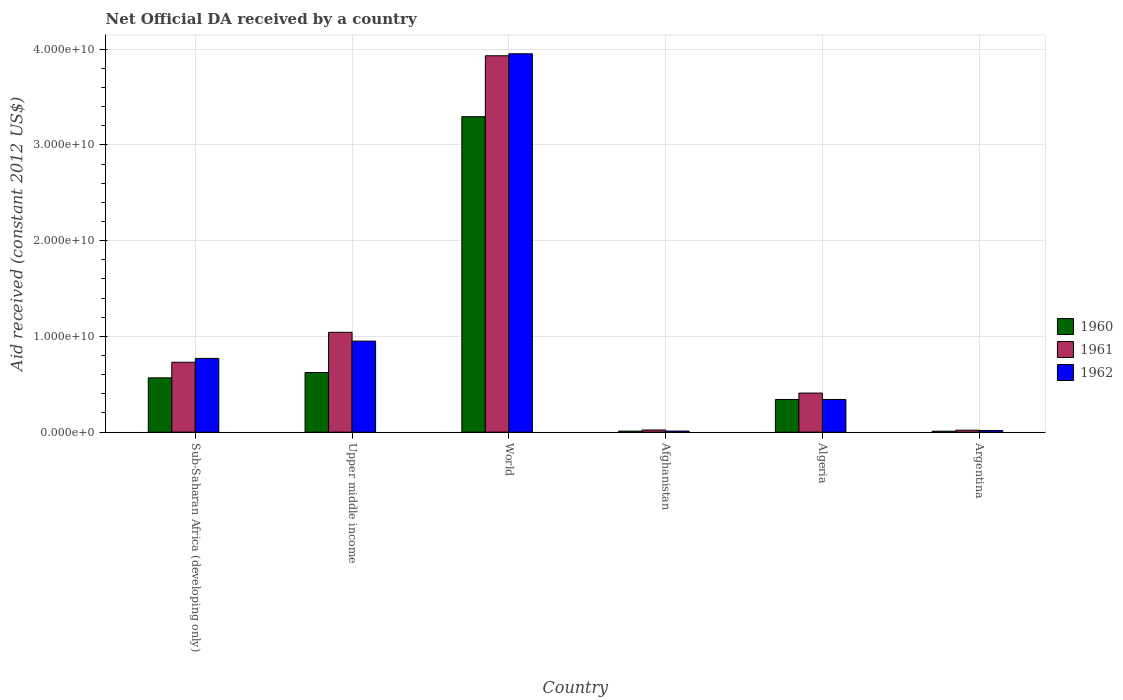Are the number of bars on each tick of the X-axis equal?
Your response must be concise. Yes. How many bars are there on the 2nd tick from the left?
Your answer should be very brief. 3. How many bars are there on the 5th tick from the right?
Give a very brief answer. 3. What is the label of the 4th group of bars from the left?
Provide a short and direct response. Afghanistan. What is the net official development assistance aid received in 1960 in Upper middle income?
Offer a very short reply. 6.23e+09. Across all countries, what is the maximum net official development assistance aid received in 1960?
Keep it short and to the point. 3.29e+1. Across all countries, what is the minimum net official development assistance aid received in 1962?
Offer a terse response. 1.12e+08. In which country was the net official development assistance aid received in 1962 minimum?
Offer a terse response. Afghanistan. What is the total net official development assistance aid received in 1960 in the graph?
Provide a short and direct response. 4.85e+1. What is the difference between the net official development assistance aid received in 1962 in Sub-Saharan Africa (developing only) and that in World?
Your answer should be very brief. -3.18e+1. What is the difference between the net official development assistance aid received in 1962 in Sub-Saharan Africa (developing only) and the net official development assistance aid received in 1961 in Afghanistan?
Provide a short and direct response. 7.47e+09. What is the average net official development assistance aid received in 1961 per country?
Your answer should be compact. 1.03e+1. What is the difference between the net official development assistance aid received of/in 1962 and net official development assistance aid received of/in 1961 in World?
Provide a short and direct response. 2.05e+08. In how many countries, is the net official development assistance aid received in 1960 greater than 2000000000 US$?
Give a very brief answer. 4. What is the ratio of the net official development assistance aid received in 1962 in Afghanistan to that in Argentina?
Offer a terse response. 0.64. Is the net official development assistance aid received in 1962 in Sub-Saharan Africa (developing only) less than that in Upper middle income?
Give a very brief answer. Yes. Is the difference between the net official development assistance aid received in 1962 in Algeria and World greater than the difference between the net official development assistance aid received in 1961 in Algeria and World?
Your answer should be compact. No. What is the difference between the highest and the second highest net official development assistance aid received in 1962?
Ensure brevity in your answer.  3.00e+1. What is the difference between the highest and the lowest net official development assistance aid received in 1962?
Provide a short and direct response. 3.94e+1. Is the sum of the net official development assistance aid received in 1960 in Afghanistan and Argentina greater than the maximum net official development assistance aid received in 1962 across all countries?
Keep it short and to the point. No. Is it the case that in every country, the sum of the net official development assistance aid received in 1962 and net official development assistance aid received in 1960 is greater than the net official development assistance aid received in 1961?
Offer a very short reply. No. How many bars are there?
Your response must be concise. 18. How many countries are there in the graph?
Provide a short and direct response. 6. What is the difference between two consecutive major ticks on the Y-axis?
Your answer should be very brief. 1.00e+1. Are the values on the major ticks of Y-axis written in scientific E-notation?
Ensure brevity in your answer.  Yes. Does the graph contain any zero values?
Offer a terse response. No. Does the graph contain grids?
Provide a succinct answer. Yes. How many legend labels are there?
Provide a short and direct response. 3. How are the legend labels stacked?
Provide a short and direct response. Vertical. What is the title of the graph?
Offer a very short reply. Net Official DA received by a country. What is the label or title of the Y-axis?
Provide a succinct answer. Aid received (constant 2012 US$). What is the Aid received (constant 2012 US$) of 1960 in Sub-Saharan Africa (developing only)?
Offer a terse response. 5.67e+09. What is the Aid received (constant 2012 US$) of 1961 in Sub-Saharan Africa (developing only)?
Your response must be concise. 7.30e+09. What is the Aid received (constant 2012 US$) in 1962 in Sub-Saharan Africa (developing only)?
Make the answer very short. 7.70e+09. What is the Aid received (constant 2012 US$) in 1960 in Upper middle income?
Provide a short and direct response. 6.23e+09. What is the Aid received (constant 2012 US$) in 1961 in Upper middle income?
Your answer should be very brief. 1.04e+1. What is the Aid received (constant 2012 US$) of 1962 in Upper middle income?
Offer a very short reply. 9.51e+09. What is the Aid received (constant 2012 US$) of 1960 in World?
Offer a terse response. 3.29e+1. What is the Aid received (constant 2012 US$) of 1961 in World?
Provide a succinct answer. 3.93e+1. What is the Aid received (constant 2012 US$) in 1962 in World?
Provide a short and direct response. 3.95e+1. What is the Aid received (constant 2012 US$) in 1960 in Afghanistan?
Give a very brief answer. 1.10e+08. What is the Aid received (constant 2012 US$) in 1961 in Afghanistan?
Ensure brevity in your answer.  2.26e+08. What is the Aid received (constant 2012 US$) of 1962 in Afghanistan?
Keep it short and to the point. 1.12e+08. What is the Aid received (constant 2012 US$) of 1960 in Algeria?
Keep it short and to the point. 3.41e+09. What is the Aid received (constant 2012 US$) in 1961 in Algeria?
Keep it short and to the point. 4.08e+09. What is the Aid received (constant 2012 US$) of 1962 in Algeria?
Make the answer very short. 3.41e+09. What is the Aid received (constant 2012 US$) of 1960 in Argentina?
Offer a very short reply. 9.55e+07. What is the Aid received (constant 2012 US$) of 1961 in Argentina?
Offer a very short reply. 2.05e+08. What is the Aid received (constant 2012 US$) in 1962 in Argentina?
Keep it short and to the point. 1.75e+08. Across all countries, what is the maximum Aid received (constant 2012 US$) of 1960?
Ensure brevity in your answer.  3.29e+1. Across all countries, what is the maximum Aid received (constant 2012 US$) in 1961?
Keep it short and to the point. 3.93e+1. Across all countries, what is the maximum Aid received (constant 2012 US$) of 1962?
Your answer should be compact. 3.95e+1. Across all countries, what is the minimum Aid received (constant 2012 US$) in 1960?
Ensure brevity in your answer.  9.55e+07. Across all countries, what is the minimum Aid received (constant 2012 US$) of 1961?
Ensure brevity in your answer.  2.05e+08. Across all countries, what is the minimum Aid received (constant 2012 US$) in 1962?
Ensure brevity in your answer.  1.12e+08. What is the total Aid received (constant 2012 US$) of 1960 in the graph?
Offer a very short reply. 4.85e+1. What is the total Aid received (constant 2012 US$) in 1961 in the graph?
Offer a terse response. 6.15e+1. What is the total Aid received (constant 2012 US$) in 1962 in the graph?
Offer a very short reply. 6.04e+1. What is the difference between the Aid received (constant 2012 US$) of 1960 in Sub-Saharan Africa (developing only) and that in Upper middle income?
Make the answer very short. -5.58e+08. What is the difference between the Aid received (constant 2012 US$) in 1961 in Sub-Saharan Africa (developing only) and that in Upper middle income?
Ensure brevity in your answer.  -3.13e+09. What is the difference between the Aid received (constant 2012 US$) in 1962 in Sub-Saharan Africa (developing only) and that in Upper middle income?
Your answer should be very brief. -1.81e+09. What is the difference between the Aid received (constant 2012 US$) in 1960 in Sub-Saharan Africa (developing only) and that in World?
Give a very brief answer. -2.73e+1. What is the difference between the Aid received (constant 2012 US$) in 1961 in Sub-Saharan Africa (developing only) and that in World?
Provide a succinct answer. -3.20e+1. What is the difference between the Aid received (constant 2012 US$) of 1962 in Sub-Saharan Africa (developing only) and that in World?
Your answer should be very brief. -3.18e+1. What is the difference between the Aid received (constant 2012 US$) in 1960 in Sub-Saharan Africa (developing only) and that in Afghanistan?
Offer a very short reply. 5.56e+09. What is the difference between the Aid received (constant 2012 US$) in 1961 in Sub-Saharan Africa (developing only) and that in Afghanistan?
Your answer should be very brief. 7.07e+09. What is the difference between the Aid received (constant 2012 US$) in 1962 in Sub-Saharan Africa (developing only) and that in Afghanistan?
Keep it short and to the point. 7.59e+09. What is the difference between the Aid received (constant 2012 US$) in 1960 in Sub-Saharan Africa (developing only) and that in Algeria?
Make the answer very short. 2.26e+09. What is the difference between the Aid received (constant 2012 US$) of 1961 in Sub-Saharan Africa (developing only) and that in Algeria?
Offer a terse response. 3.22e+09. What is the difference between the Aid received (constant 2012 US$) of 1962 in Sub-Saharan Africa (developing only) and that in Algeria?
Offer a very short reply. 4.29e+09. What is the difference between the Aid received (constant 2012 US$) of 1960 in Sub-Saharan Africa (developing only) and that in Argentina?
Provide a short and direct response. 5.58e+09. What is the difference between the Aid received (constant 2012 US$) of 1961 in Sub-Saharan Africa (developing only) and that in Argentina?
Offer a very short reply. 7.09e+09. What is the difference between the Aid received (constant 2012 US$) in 1962 in Sub-Saharan Africa (developing only) and that in Argentina?
Your answer should be compact. 7.52e+09. What is the difference between the Aid received (constant 2012 US$) of 1960 in Upper middle income and that in World?
Make the answer very short. -2.67e+1. What is the difference between the Aid received (constant 2012 US$) of 1961 in Upper middle income and that in World?
Provide a succinct answer. -2.89e+1. What is the difference between the Aid received (constant 2012 US$) of 1962 in Upper middle income and that in World?
Make the answer very short. -3.00e+1. What is the difference between the Aid received (constant 2012 US$) in 1960 in Upper middle income and that in Afghanistan?
Keep it short and to the point. 6.12e+09. What is the difference between the Aid received (constant 2012 US$) of 1961 in Upper middle income and that in Afghanistan?
Offer a very short reply. 1.02e+1. What is the difference between the Aid received (constant 2012 US$) of 1962 in Upper middle income and that in Afghanistan?
Provide a succinct answer. 9.39e+09. What is the difference between the Aid received (constant 2012 US$) of 1960 in Upper middle income and that in Algeria?
Your answer should be compact. 2.82e+09. What is the difference between the Aid received (constant 2012 US$) of 1961 in Upper middle income and that in Algeria?
Offer a terse response. 6.35e+09. What is the difference between the Aid received (constant 2012 US$) in 1962 in Upper middle income and that in Algeria?
Ensure brevity in your answer.  6.09e+09. What is the difference between the Aid received (constant 2012 US$) in 1960 in Upper middle income and that in Argentina?
Provide a succinct answer. 6.13e+09. What is the difference between the Aid received (constant 2012 US$) of 1961 in Upper middle income and that in Argentina?
Your answer should be very brief. 1.02e+1. What is the difference between the Aid received (constant 2012 US$) in 1962 in Upper middle income and that in Argentina?
Your answer should be compact. 9.33e+09. What is the difference between the Aid received (constant 2012 US$) of 1960 in World and that in Afghanistan?
Offer a terse response. 3.28e+1. What is the difference between the Aid received (constant 2012 US$) of 1961 in World and that in Afghanistan?
Make the answer very short. 3.91e+1. What is the difference between the Aid received (constant 2012 US$) in 1962 in World and that in Afghanistan?
Keep it short and to the point. 3.94e+1. What is the difference between the Aid received (constant 2012 US$) in 1960 in World and that in Algeria?
Your response must be concise. 2.95e+1. What is the difference between the Aid received (constant 2012 US$) in 1961 in World and that in Algeria?
Your answer should be compact. 3.52e+1. What is the difference between the Aid received (constant 2012 US$) of 1962 in World and that in Algeria?
Give a very brief answer. 3.61e+1. What is the difference between the Aid received (constant 2012 US$) in 1960 in World and that in Argentina?
Your answer should be very brief. 3.28e+1. What is the difference between the Aid received (constant 2012 US$) in 1961 in World and that in Argentina?
Ensure brevity in your answer.  3.91e+1. What is the difference between the Aid received (constant 2012 US$) in 1962 in World and that in Argentina?
Give a very brief answer. 3.93e+1. What is the difference between the Aid received (constant 2012 US$) in 1960 in Afghanistan and that in Algeria?
Make the answer very short. -3.30e+09. What is the difference between the Aid received (constant 2012 US$) in 1961 in Afghanistan and that in Algeria?
Keep it short and to the point. -3.85e+09. What is the difference between the Aid received (constant 2012 US$) in 1962 in Afghanistan and that in Algeria?
Ensure brevity in your answer.  -3.30e+09. What is the difference between the Aid received (constant 2012 US$) of 1960 in Afghanistan and that in Argentina?
Offer a terse response. 1.43e+07. What is the difference between the Aid received (constant 2012 US$) in 1961 in Afghanistan and that in Argentina?
Your answer should be very brief. 2.05e+07. What is the difference between the Aid received (constant 2012 US$) of 1962 in Afghanistan and that in Argentina?
Keep it short and to the point. -6.28e+07. What is the difference between the Aid received (constant 2012 US$) in 1960 in Algeria and that in Argentina?
Ensure brevity in your answer.  3.32e+09. What is the difference between the Aid received (constant 2012 US$) of 1961 in Algeria and that in Argentina?
Give a very brief answer. 3.88e+09. What is the difference between the Aid received (constant 2012 US$) of 1962 in Algeria and that in Argentina?
Keep it short and to the point. 3.24e+09. What is the difference between the Aid received (constant 2012 US$) in 1960 in Sub-Saharan Africa (developing only) and the Aid received (constant 2012 US$) in 1961 in Upper middle income?
Offer a terse response. -4.76e+09. What is the difference between the Aid received (constant 2012 US$) of 1960 in Sub-Saharan Africa (developing only) and the Aid received (constant 2012 US$) of 1962 in Upper middle income?
Keep it short and to the point. -3.83e+09. What is the difference between the Aid received (constant 2012 US$) of 1961 in Sub-Saharan Africa (developing only) and the Aid received (constant 2012 US$) of 1962 in Upper middle income?
Make the answer very short. -2.21e+09. What is the difference between the Aid received (constant 2012 US$) in 1960 in Sub-Saharan Africa (developing only) and the Aid received (constant 2012 US$) in 1961 in World?
Offer a terse response. -3.36e+1. What is the difference between the Aid received (constant 2012 US$) of 1960 in Sub-Saharan Africa (developing only) and the Aid received (constant 2012 US$) of 1962 in World?
Your answer should be compact. -3.38e+1. What is the difference between the Aid received (constant 2012 US$) in 1961 in Sub-Saharan Africa (developing only) and the Aid received (constant 2012 US$) in 1962 in World?
Your response must be concise. -3.22e+1. What is the difference between the Aid received (constant 2012 US$) in 1960 in Sub-Saharan Africa (developing only) and the Aid received (constant 2012 US$) in 1961 in Afghanistan?
Offer a terse response. 5.45e+09. What is the difference between the Aid received (constant 2012 US$) in 1960 in Sub-Saharan Africa (developing only) and the Aid received (constant 2012 US$) in 1962 in Afghanistan?
Offer a terse response. 5.56e+09. What is the difference between the Aid received (constant 2012 US$) of 1961 in Sub-Saharan Africa (developing only) and the Aid received (constant 2012 US$) of 1962 in Afghanistan?
Offer a terse response. 7.19e+09. What is the difference between the Aid received (constant 2012 US$) in 1960 in Sub-Saharan Africa (developing only) and the Aid received (constant 2012 US$) in 1961 in Algeria?
Your answer should be compact. 1.59e+09. What is the difference between the Aid received (constant 2012 US$) in 1960 in Sub-Saharan Africa (developing only) and the Aid received (constant 2012 US$) in 1962 in Algeria?
Keep it short and to the point. 2.26e+09. What is the difference between the Aid received (constant 2012 US$) in 1961 in Sub-Saharan Africa (developing only) and the Aid received (constant 2012 US$) in 1962 in Algeria?
Offer a very short reply. 3.88e+09. What is the difference between the Aid received (constant 2012 US$) of 1960 in Sub-Saharan Africa (developing only) and the Aid received (constant 2012 US$) of 1961 in Argentina?
Make the answer very short. 5.47e+09. What is the difference between the Aid received (constant 2012 US$) of 1960 in Sub-Saharan Africa (developing only) and the Aid received (constant 2012 US$) of 1962 in Argentina?
Make the answer very short. 5.50e+09. What is the difference between the Aid received (constant 2012 US$) in 1961 in Sub-Saharan Africa (developing only) and the Aid received (constant 2012 US$) in 1962 in Argentina?
Make the answer very short. 7.12e+09. What is the difference between the Aid received (constant 2012 US$) in 1960 in Upper middle income and the Aid received (constant 2012 US$) in 1961 in World?
Provide a succinct answer. -3.31e+1. What is the difference between the Aid received (constant 2012 US$) of 1960 in Upper middle income and the Aid received (constant 2012 US$) of 1962 in World?
Ensure brevity in your answer.  -3.33e+1. What is the difference between the Aid received (constant 2012 US$) in 1961 in Upper middle income and the Aid received (constant 2012 US$) in 1962 in World?
Give a very brief answer. -2.91e+1. What is the difference between the Aid received (constant 2012 US$) of 1960 in Upper middle income and the Aid received (constant 2012 US$) of 1961 in Afghanistan?
Offer a terse response. 6.00e+09. What is the difference between the Aid received (constant 2012 US$) of 1960 in Upper middle income and the Aid received (constant 2012 US$) of 1962 in Afghanistan?
Keep it short and to the point. 6.12e+09. What is the difference between the Aid received (constant 2012 US$) in 1961 in Upper middle income and the Aid received (constant 2012 US$) in 1962 in Afghanistan?
Your answer should be compact. 1.03e+1. What is the difference between the Aid received (constant 2012 US$) of 1960 in Upper middle income and the Aid received (constant 2012 US$) of 1961 in Algeria?
Provide a succinct answer. 2.15e+09. What is the difference between the Aid received (constant 2012 US$) in 1960 in Upper middle income and the Aid received (constant 2012 US$) in 1962 in Algeria?
Offer a terse response. 2.82e+09. What is the difference between the Aid received (constant 2012 US$) of 1961 in Upper middle income and the Aid received (constant 2012 US$) of 1962 in Algeria?
Your response must be concise. 7.01e+09. What is the difference between the Aid received (constant 2012 US$) in 1960 in Upper middle income and the Aid received (constant 2012 US$) in 1961 in Argentina?
Provide a short and direct response. 6.02e+09. What is the difference between the Aid received (constant 2012 US$) of 1960 in Upper middle income and the Aid received (constant 2012 US$) of 1962 in Argentina?
Ensure brevity in your answer.  6.05e+09. What is the difference between the Aid received (constant 2012 US$) of 1961 in Upper middle income and the Aid received (constant 2012 US$) of 1962 in Argentina?
Your answer should be compact. 1.03e+1. What is the difference between the Aid received (constant 2012 US$) in 1960 in World and the Aid received (constant 2012 US$) in 1961 in Afghanistan?
Keep it short and to the point. 3.27e+1. What is the difference between the Aid received (constant 2012 US$) in 1960 in World and the Aid received (constant 2012 US$) in 1962 in Afghanistan?
Your answer should be compact. 3.28e+1. What is the difference between the Aid received (constant 2012 US$) in 1961 in World and the Aid received (constant 2012 US$) in 1962 in Afghanistan?
Provide a succinct answer. 3.92e+1. What is the difference between the Aid received (constant 2012 US$) in 1960 in World and the Aid received (constant 2012 US$) in 1961 in Algeria?
Provide a succinct answer. 2.89e+1. What is the difference between the Aid received (constant 2012 US$) of 1960 in World and the Aid received (constant 2012 US$) of 1962 in Algeria?
Provide a succinct answer. 2.95e+1. What is the difference between the Aid received (constant 2012 US$) of 1961 in World and the Aid received (constant 2012 US$) of 1962 in Algeria?
Give a very brief answer. 3.59e+1. What is the difference between the Aid received (constant 2012 US$) of 1960 in World and the Aid received (constant 2012 US$) of 1961 in Argentina?
Make the answer very short. 3.27e+1. What is the difference between the Aid received (constant 2012 US$) of 1960 in World and the Aid received (constant 2012 US$) of 1962 in Argentina?
Offer a terse response. 3.28e+1. What is the difference between the Aid received (constant 2012 US$) of 1961 in World and the Aid received (constant 2012 US$) of 1962 in Argentina?
Give a very brief answer. 3.91e+1. What is the difference between the Aid received (constant 2012 US$) in 1960 in Afghanistan and the Aid received (constant 2012 US$) in 1961 in Algeria?
Offer a very short reply. -3.97e+09. What is the difference between the Aid received (constant 2012 US$) in 1960 in Afghanistan and the Aid received (constant 2012 US$) in 1962 in Algeria?
Offer a very short reply. -3.30e+09. What is the difference between the Aid received (constant 2012 US$) in 1961 in Afghanistan and the Aid received (constant 2012 US$) in 1962 in Algeria?
Your answer should be compact. -3.19e+09. What is the difference between the Aid received (constant 2012 US$) of 1960 in Afghanistan and the Aid received (constant 2012 US$) of 1961 in Argentina?
Your answer should be compact. -9.55e+07. What is the difference between the Aid received (constant 2012 US$) in 1960 in Afghanistan and the Aid received (constant 2012 US$) in 1962 in Argentina?
Provide a succinct answer. -6.54e+07. What is the difference between the Aid received (constant 2012 US$) in 1961 in Afghanistan and the Aid received (constant 2012 US$) in 1962 in Argentina?
Offer a very short reply. 5.05e+07. What is the difference between the Aid received (constant 2012 US$) in 1960 in Algeria and the Aid received (constant 2012 US$) in 1961 in Argentina?
Offer a terse response. 3.21e+09. What is the difference between the Aid received (constant 2012 US$) in 1960 in Algeria and the Aid received (constant 2012 US$) in 1962 in Argentina?
Offer a very short reply. 3.24e+09. What is the difference between the Aid received (constant 2012 US$) of 1961 in Algeria and the Aid received (constant 2012 US$) of 1962 in Argentina?
Keep it short and to the point. 3.91e+09. What is the average Aid received (constant 2012 US$) of 1960 per country?
Ensure brevity in your answer.  8.08e+09. What is the average Aid received (constant 2012 US$) of 1961 per country?
Your answer should be compact. 1.03e+1. What is the average Aid received (constant 2012 US$) of 1962 per country?
Offer a terse response. 1.01e+1. What is the difference between the Aid received (constant 2012 US$) in 1960 and Aid received (constant 2012 US$) in 1961 in Sub-Saharan Africa (developing only)?
Keep it short and to the point. -1.63e+09. What is the difference between the Aid received (constant 2012 US$) in 1960 and Aid received (constant 2012 US$) in 1962 in Sub-Saharan Africa (developing only)?
Make the answer very short. -2.03e+09. What is the difference between the Aid received (constant 2012 US$) of 1961 and Aid received (constant 2012 US$) of 1962 in Sub-Saharan Africa (developing only)?
Give a very brief answer. -4.02e+08. What is the difference between the Aid received (constant 2012 US$) of 1960 and Aid received (constant 2012 US$) of 1961 in Upper middle income?
Ensure brevity in your answer.  -4.20e+09. What is the difference between the Aid received (constant 2012 US$) of 1960 and Aid received (constant 2012 US$) of 1962 in Upper middle income?
Provide a succinct answer. -3.28e+09. What is the difference between the Aid received (constant 2012 US$) in 1961 and Aid received (constant 2012 US$) in 1962 in Upper middle income?
Your answer should be compact. 9.22e+08. What is the difference between the Aid received (constant 2012 US$) in 1960 and Aid received (constant 2012 US$) in 1961 in World?
Your answer should be very brief. -6.36e+09. What is the difference between the Aid received (constant 2012 US$) of 1960 and Aid received (constant 2012 US$) of 1962 in World?
Keep it short and to the point. -6.57e+09. What is the difference between the Aid received (constant 2012 US$) in 1961 and Aid received (constant 2012 US$) in 1962 in World?
Give a very brief answer. -2.05e+08. What is the difference between the Aid received (constant 2012 US$) in 1960 and Aid received (constant 2012 US$) in 1961 in Afghanistan?
Keep it short and to the point. -1.16e+08. What is the difference between the Aid received (constant 2012 US$) in 1960 and Aid received (constant 2012 US$) in 1962 in Afghanistan?
Offer a terse response. -2.63e+06. What is the difference between the Aid received (constant 2012 US$) of 1961 and Aid received (constant 2012 US$) of 1962 in Afghanistan?
Your answer should be very brief. 1.13e+08. What is the difference between the Aid received (constant 2012 US$) of 1960 and Aid received (constant 2012 US$) of 1961 in Algeria?
Provide a succinct answer. -6.69e+08. What is the difference between the Aid received (constant 2012 US$) of 1960 and Aid received (constant 2012 US$) of 1962 in Algeria?
Provide a short and direct response. -2.85e+06. What is the difference between the Aid received (constant 2012 US$) in 1961 and Aid received (constant 2012 US$) in 1962 in Algeria?
Make the answer very short. 6.66e+08. What is the difference between the Aid received (constant 2012 US$) of 1960 and Aid received (constant 2012 US$) of 1961 in Argentina?
Keep it short and to the point. -1.10e+08. What is the difference between the Aid received (constant 2012 US$) of 1960 and Aid received (constant 2012 US$) of 1962 in Argentina?
Your answer should be very brief. -7.98e+07. What is the difference between the Aid received (constant 2012 US$) of 1961 and Aid received (constant 2012 US$) of 1962 in Argentina?
Make the answer very short. 3.01e+07. What is the ratio of the Aid received (constant 2012 US$) of 1960 in Sub-Saharan Africa (developing only) to that in Upper middle income?
Offer a terse response. 0.91. What is the ratio of the Aid received (constant 2012 US$) in 1961 in Sub-Saharan Africa (developing only) to that in Upper middle income?
Give a very brief answer. 0.7. What is the ratio of the Aid received (constant 2012 US$) of 1962 in Sub-Saharan Africa (developing only) to that in Upper middle income?
Your answer should be compact. 0.81. What is the ratio of the Aid received (constant 2012 US$) in 1960 in Sub-Saharan Africa (developing only) to that in World?
Offer a very short reply. 0.17. What is the ratio of the Aid received (constant 2012 US$) in 1961 in Sub-Saharan Africa (developing only) to that in World?
Your response must be concise. 0.19. What is the ratio of the Aid received (constant 2012 US$) of 1962 in Sub-Saharan Africa (developing only) to that in World?
Give a very brief answer. 0.19. What is the ratio of the Aid received (constant 2012 US$) in 1960 in Sub-Saharan Africa (developing only) to that in Afghanistan?
Offer a terse response. 51.65. What is the ratio of the Aid received (constant 2012 US$) of 1961 in Sub-Saharan Africa (developing only) to that in Afghanistan?
Offer a very short reply. 32.33. What is the ratio of the Aid received (constant 2012 US$) in 1962 in Sub-Saharan Africa (developing only) to that in Afghanistan?
Keep it short and to the point. 68.48. What is the ratio of the Aid received (constant 2012 US$) of 1960 in Sub-Saharan Africa (developing only) to that in Algeria?
Your answer should be very brief. 1.66. What is the ratio of the Aid received (constant 2012 US$) in 1961 in Sub-Saharan Africa (developing only) to that in Algeria?
Your response must be concise. 1.79. What is the ratio of the Aid received (constant 2012 US$) of 1962 in Sub-Saharan Africa (developing only) to that in Algeria?
Offer a very short reply. 2.26. What is the ratio of the Aid received (constant 2012 US$) in 1960 in Sub-Saharan Africa (developing only) to that in Argentina?
Give a very brief answer. 59.41. What is the ratio of the Aid received (constant 2012 US$) of 1961 in Sub-Saharan Africa (developing only) to that in Argentina?
Your answer should be very brief. 35.55. What is the ratio of the Aid received (constant 2012 US$) of 1962 in Sub-Saharan Africa (developing only) to that in Argentina?
Make the answer very short. 43.94. What is the ratio of the Aid received (constant 2012 US$) in 1960 in Upper middle income to that in World?
Provide a short and direct response. 0.19. What is the ratio of the Aid received (constant 2012 US$) of 1961 in Upper middle income to that in World?
Your response must be concise. 0.27. What is the ratio of the Aid received (constant 2012 US$) of 1962 in Upper middle income to that in World?
Offer a very short reply. 0.24. What is the ratio of the Aid received (constant 2012 US$) of 1960 in Upper middle income to that in Afghanistan?
Your answer should be compact. 56.73. What is the ratio of the Aid received (constant 2012 US$) of 1961 in Upper middle income to that in Afghanistan?
Provide a succinct answer. 46.2. What is the ratio of the Aid received (constant 2012 US$) of 1962 in Upper middle income to that in Afghanistan?
Provide a short and direct response. 84.54. What is the ratio of the Aid received (constant 2012 US$) in 1960 in Upper middle income to that in Algeria?
Your response must be concise. 1.83. What is the ratio of the Aid received (constant 2012 US$) in 1961 in Upper middle income to that in Algeria?
Provide a succinct answer. 2.56. What is the ratio of the Aid received (constant 2012 US$) in 1962 in Upper middle income to that in Algeria?
Make the answer very short. 2.78. What is the ratio of the Aid received (constant 2012 US$) in 1960 in Upper middle income to that in Argentina?
Make the answer very short. 65.25. What is the ratio of the Aid received (constant 2012 US$) in 1961 in Upper middle income to that in Argentina?
Keep it short and to the point. 50.8. What is the ratio of the Aid received (constant 2012 US$) in 1962 in Upper middle income to that in Argentina?
Your response must be concise. 54.25. What is the ratio of the Aid received (constant 2012 US$) of 1960 in World to that in Afghanistan?
Your answer should be very brief. 300.02. What is the ratio of the Aid received (constant 2012 US$) in 1961 in World to that in Afghanistan?
Provide a short and direct response. 174.12. What is the ratio of the Aid received (constant 2012 US$) in 1962 in World to that in Afghanistan?
Your answer should be very brief. 351.41. What is the ratio of the Aid received (constant 2012 US$) of 1960 in World to that in Algeria?
Your response must be concise. 9.66. What is the ratio of the Aid received (constant 2012 US$) of 1961 in World to that in Algeria?
Keep it short and to the point. 9.63. What is the ratio of the Aid received (constant 2012 US$) of 1962 in World to that in Algeria?
Provide a succinct answer. 11.57. What is the ratio of the Aid received (constant 2012 US$) of 1960 in World to that in Argentina?
Provide a short and direct response. 345.08. What is the ratio of the Aid received (constant 2012 US$) in 1961 in World to that in Argentina?
Provide a succinct answer. 191.48. What is the ratio of the Aid received (constant 2012 US$) of 1962 in World to that in Argentina?
Give a very brief answer. 225.49. What is the ratio of the Aid received (constant 2012 US$) in 1960 in Afghanistan to that in Algeria?
Offer a very short reply. 0.03. What is the ratio of the Aid received (constant 2012 US$) of 1961 in Afghanistan to that in Algeria?
Make the answer very short. 0.06. What is the ratio of the Aid received (constant 2012 US$) in 1962 in Afghanistan to that in Algeria?
Your answer should be very brief. 0.03. What is the ratio of the Aid received (constant 2012 US$) in 1960 in Afghanistan to that in Argentina?
Provide a succinct answer. 1.15. What is the ratio of the Aid received (constant 2012 US$) of 1961 in Afghanistan to that in Argentina?
Provide a succinct answer. 1.1. What is the ratio of the Aid received (constant 2012 US$) in 1962 in Afghanistan to that in Argentina?
Keep it short and to the point. 0.64. What is the ratio of the Aid received (constant 2012 US$) of 1960 in Algeria to that in Argentina?
Your answer should be compact. 35.73. What is the ratio of the Aid received (constant 2012 US$) of 1961 in Algeria to that in Argentina?
Your response must be concise. 19.88. What is the ratio of the Aid received (constant 2012 US$) of 1962 in Algeria to that in Argentina?
Keep it short and to the point. 19.48. What is the difference between the highest and the second highest Aid received (constant 2012 US$) in 1960?
Your answer should be very brief. 2.67e+1. What is the difference between the highest and the second highest Aid received (constant 2012 US$) in 1961?
Your answer should be compact. 2.89e+1. What is the difference between the highest and the second highest Aid received (constant 2012 US$) in 1962?
Offer a terse response. 3.00e+1. What is the difference between the highest and the lowest Aid received (constant 2012 US$) of 1960?
Give a very brief answer. 3.28e+1. What is the difference between the highest and the lowest Aid received (constant 2012 US$) of 1961?
Offer a very short reply. 3.91e+1. What is the difference between the highest and the lowest Aid received (constant 2012 US$) of 1962?
Your answer should be very brief. 3.94e+1. 